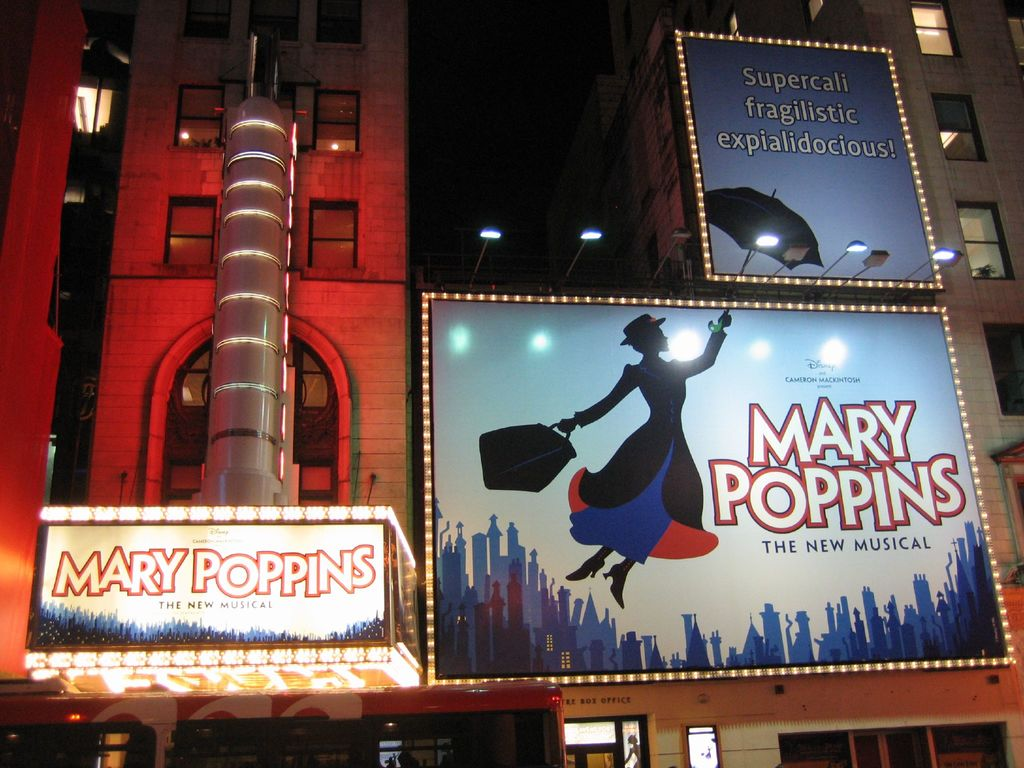What is this photo about'? The image captures a night scene at a theater showcasing "Mary Poppins The New Musical". The theater's exterior is adorned with a large, illuminated marquee that announces the musical. Two billboards flank the marquee, featuring an illustration of Mary Poppins soaring above a city skyline. The word "Supercalifragilisticexpialidocious!", a notable phrase from the musical, is prominently displayed above the character. The theater itself is a red brick building with a silver column on its left side, contributing to the overall festive and inviting atmosphere. 